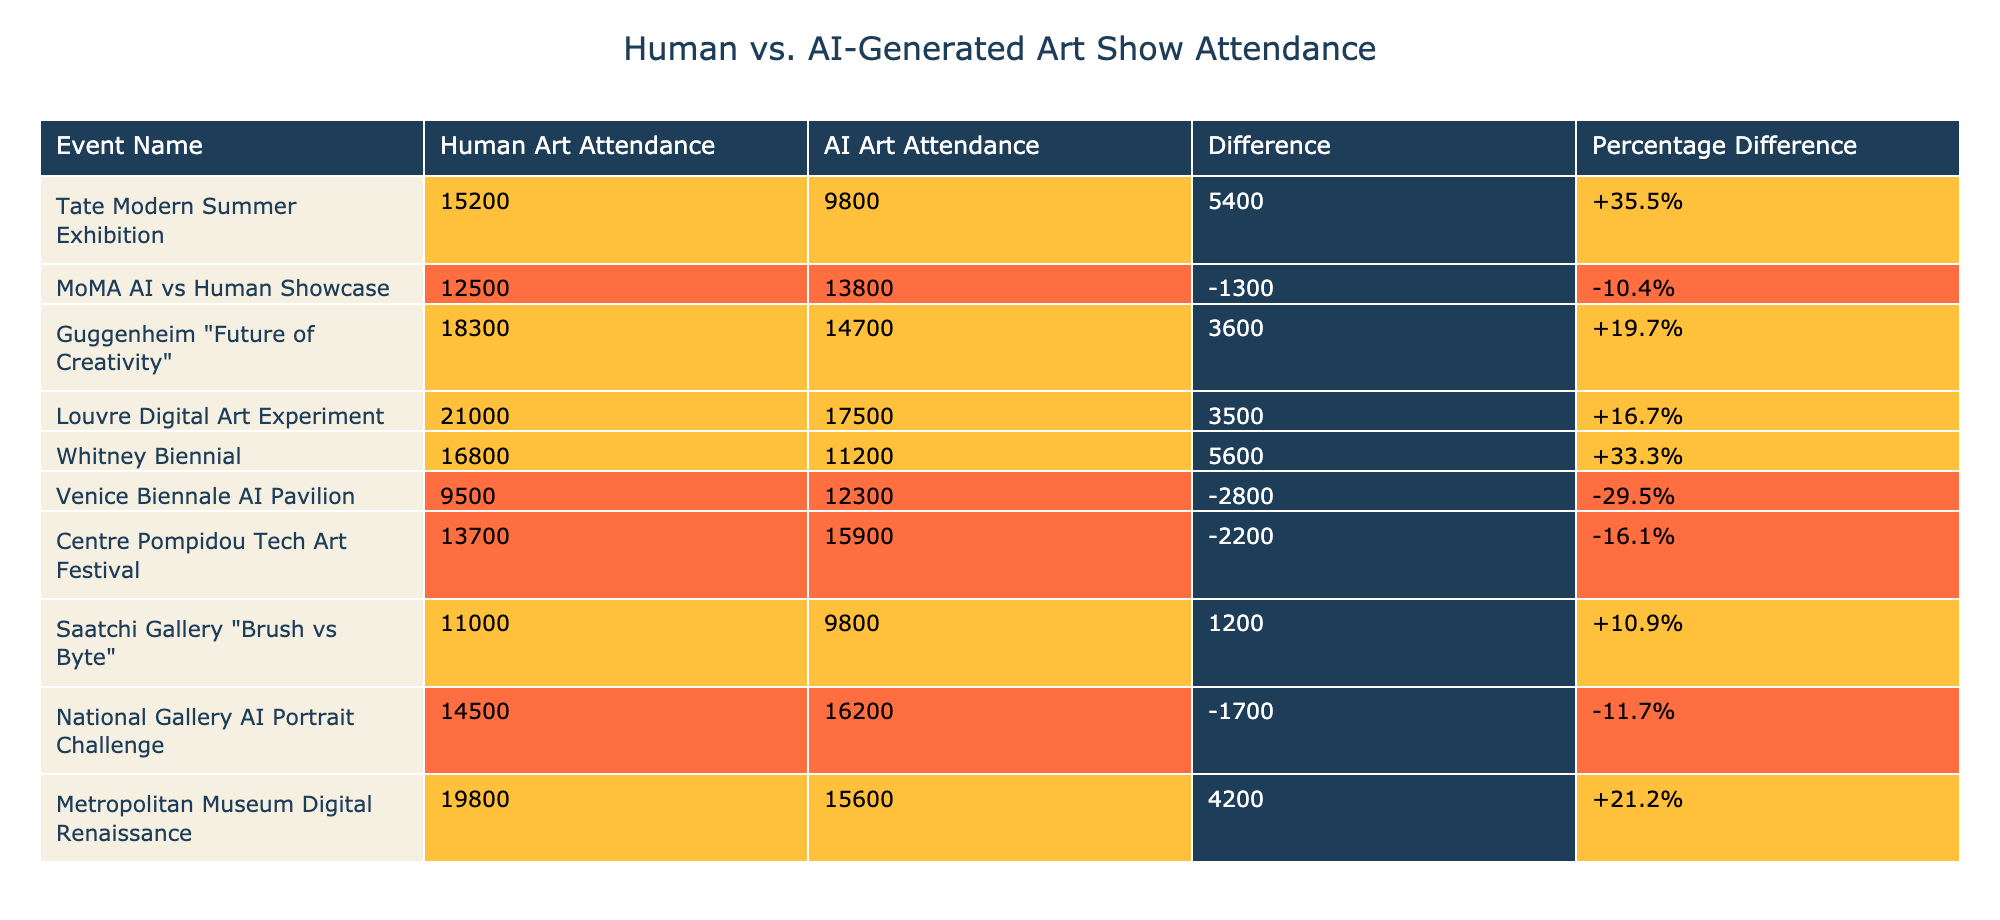What is the human art attendance for the Tate Modern Summer Exhibition? The table lists the attendance for each event. According to the row for the Tate Modern Summer Exhibition, the human art attendance is documented as 15,200.
Answer: 15,200 What is the difference in attendance for the Guggenheim "Future of Creativity" event? The difference column shows the values for all events. For the Guggenheim "Future of Creativity", the difference is shown as 3,600.
Answer: 3,600 Is there an event where AI-generated art had higher attendance than human art? The "MoMA AI vs Human Showcase" shows an AI attendance of 13,800 compared to human attendance of 12,500, indicating that AI attendance is higher.
Answer: Yes What is the total attendance for human art across all events? To find the total, we sum the human art attendance values: 15,200 + 12,500 + 18,300 + 21,000 + 16,800 + 9,500 + 13,700 + 11,000 + 14,500 + 19,800 =  158,800.
Answer: 158,800 Which event had the largest difference favoring human art? By examining the difference values, the event with the largest positive difference favoring human art is the Whitney Biennial, with a difference of 5,600.
Answer: Whitney Biennial What is the average attendance for AI-generated art? To find the average, we sum the AI art attendance values (9,800 + 13,800 + 14,700 + 17,500 + 11,200 + 12,300 + 15,900 + 9,800 + 16,200 + 15,600 = 135,000) and divide by the number of events (10), resulting in an average of 13,500.
Answer: 13,500 Is the difference in attendance for the Venice Biennale AI Pavilion negative? The difference column for the Venice Biennale AI Pavilion is reported as -2,800, indicating that the difference is indeed negative.
Answer: Yes Which event had the highest attendance for AI art? Comparing the AI art attendance figures, the Louvre Digital Art Experiment shows the highest at 17,500.
Answer: Louvre Digital Art Experiment 